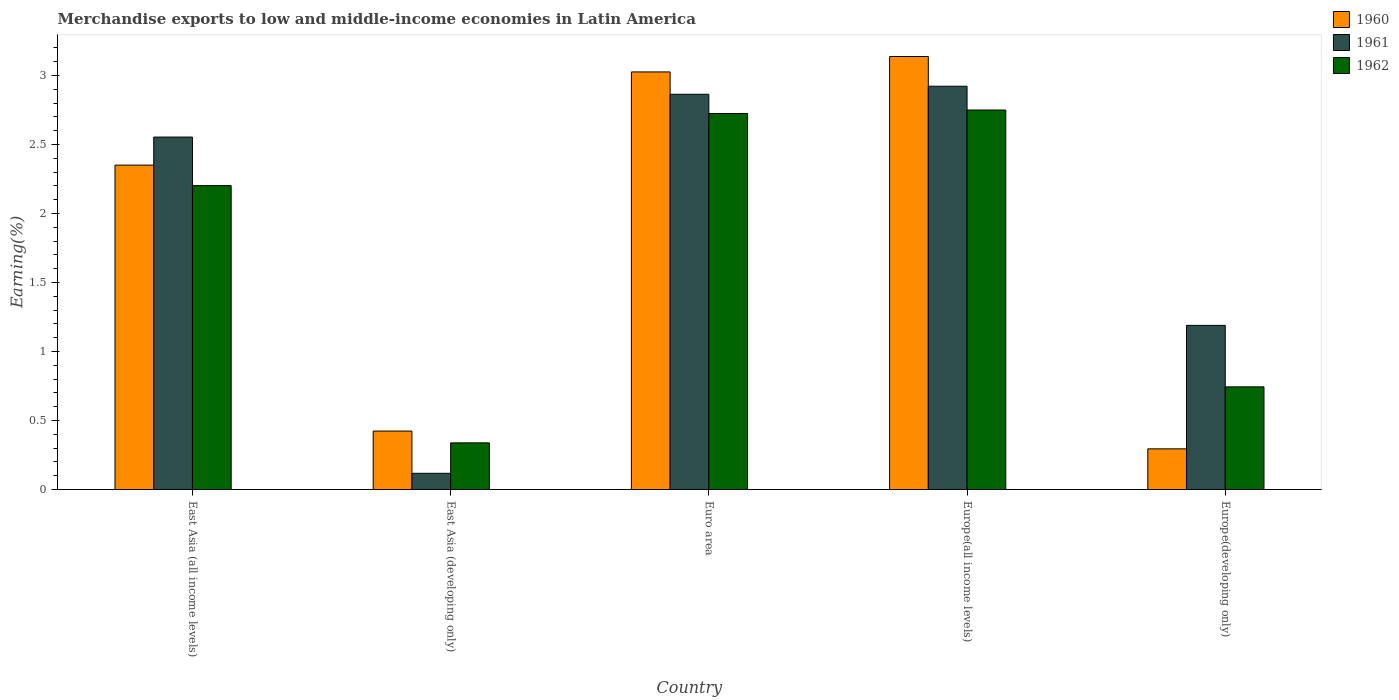How many different coloured bars are there?
Your response must be concise. 3. Are the number of bars per tick equal to the number of legend labels?
Your answer should be compact. Yes. Are the number of bars on each tick of the X-axis equal?
Your answer should be very brief. Yes. How many bars are there on the 3rd tick from the right?
Provide a succinct answer. 3. What is the label of the 1st group of bars from the left?
Provide a short and direct response. East Asia (all income levels). What is the percentage of amount earned from merchandise exports in 1960 in Europe(developing only)?
Make the answer very short. 0.29. Across all countries, what is the maximum percentage of amount earned from merchandise exports in 1960?
Keep it short and to the point. 3.14. Across all countries, what is the minimum percentage of amount earned from merchandise exports in 1960?
Your answer should be very brief. 0.29. In which country was the percentage of amount earned from merchandise exports in 1961 maximum?
Ensure brevity in your answer.  Europe(all income levels). In which country was the percentage of amount earned from merchandise exports in 1961 minimum?
Your response must be concise. East Asia (developing only). What is the total percentage of amount earned from merchandise exports in 1962 in the graph?
Your response must be concise. 8.76. What is the difference between the percentage of amount earned from merchandise exports in 1962 in East Asia (all income levels) and that in Euro area?
Make the answer very short. -0.52. What is the difference between the percentage of amount earned from merchandise exports in 1962 in Europe(all income levels) and the percentage of amount earned from merchandise exports in 1960 in Europe(developing only)?
Keep it short and to the point. 2.45. What is the average percentage of amount earned from merchandise exports in 1960 per country?
Provide a succinct answer. 1.85. What is the difference between the percentage of amount earned from merchandise exports of/in 1960 and percentage of amount earned from merchandise exports of/in 1961 in Europe(developing only)?
Offer a very short reply. -0.89. What is the ratio of the percentage of amount earned from merchandise exports in 1960 in East Asia (developing only) to that in Europe(all income levels)?
Your response must be concise. 0.13. Is the percentage of amount earned from merchandise exports in 1961 in East Asia (all income levels) less than that in Europe(developing only)?
Give a very brief answer. No. Is the difference between the percentage of amount earned from merchandise exports in 1960 in Euro area and Europe(all income levels) greater than the difference between the percentage of amount earned from merchandise exports in 1961 in Euro area and Europe(all income levels)?
Keep it short and to the point. No. What is the difference between the highest and the second highest percentage of amount earned from merchandise exports in 1961?
Offer a very short reply. 0.06. What is the difference between the highest and the lowest percentage of amount earned from merchandise exports in 1961?
Your response must be concise. 2.8. In how many countries, is the percentage of amount earned from merchandise exports in 1962 greater than the average percentage of amount earned from merchandise exports in 1962 taken over all countries?
Provide a succinct answer. 3. Is the sum of the percentage of amount earned from merchandise exports in 1962 in East Asia (developing only) and Europe(developing only) greater than the maximum percentage of amount earned from merchandise exports in 1961 across all countries?
Offer a terse response. No. What does the 2nd bar from the left in Europe(all income levels) represents?
Your answer should be compact. 1961. How many bars are there?
Your answer should be very brief. 15. What is the difference between two consecutive major ticks on the Y-axis?
Ensure brevity in your answer.  0.5. Does the graph contain any zero values?
Provide a succinct answer. No. Does the graph contain grids?
Your answer should be compact. No. What is the title of the graph?
Ensure brevity in your answer.  Merchandise exports to low and middle-income economies in Latin America. What is the label or title of the X-axis?
Ensure brevity in your answer.  Country. What is the label or title of the Y-axis?
Your answer should be compact. Earning(%). What is the Earning(%) in 1960 in East Asia (all income levels)?
Offer a very short reply. 2.35. What is the Earning(%) of 1961 in East Asia (all income levels)?
Your answer should be compact. 2.55. What is the Earning(%) of 1962 in East Asia (all income levels)?
Your answer should be compact. 2.2. What is the Earning(%) in 1960 in East Asia (developing only)?
Ensure brevity in your answer.  0.42. What is the Earning(%) in 1961 in East Asia (developing only)?
Give a very brief answer. 0.12. What is the Earning(%) of 1962 in East Asia (developing only)?
Offer a terse response. 0.34. What is the Earning(%) of 1960 in Euro area?
Offer a very short reply. 3.03. What is the Earning(%) in 1961 in Euro area?
Keep it short and to the point. 2.86. What is the Earning(%) of 1962 in Euro area?
Your response must be concise. 2.72. What is the Earning(%) of 1960 in Europe(all income levels)?
Make the answer very short. 3.14. What is the Earning(%) of 1961 in Europe(all income levels)?
Your answer should be compact. 2.92. What is the Earning(%) of 1962 in Europe(all income levels)?
Give a very brief answer. 2.75. What is the Earning(%) in 1960 in Europe(developing only)?
Give a very brief answer. 0.29. What is the Earning(%) in 1961 in Europe(developing only)?
Give a very brief answer. 1.19. What is the Earning(%) of 1962 in Europe(developing only)?
Keep it short and to the point. 0.74. Across all countries, what is the maximum Earning(%) of 1960?
Ensure brevity in your answer.  3.14. Across all countries, what is the maximum Earning(%) of 1961?
Your answer should be very brief. 2.92. Across all countries, what is the maximum Earning(%) in 1962?
Your response must be concise. 2.75. Across all countries, what is the minimum Earning(%) in 1960?
Provide a short and direct response. 0.29. Across all countries, what is the minimum Earning(%) of 1961?
Give a very brief answer. 0.12. Across all countries, what is the minimum Earning(%) in 1962?
Provide a succinct answer. 0.34. What is the total Earning(%) in 1960 in the graph?
Your answer should be very brief. 9.23. What is the total Earning(%) of 1961 in the graph?
Your answer should be compact. 9.65. What is the total Earning(%) of 1962 in the graph?
Your answer should be very brief. 8.76. What is the difference between the Earning(%) of 1960 in East Asia (all income levels) and that in East Asia (developing only)?
Keep it short and to the point. 1.93. What is the difference between the Earning(%) in 1961 in East Asia (all income levels) and that in East Asia (developing only)?
Your answer should be compact. 2.44. What is the difference between the Earning(%) in 1962 in East Asia (all income levels) and that in East Asia (developing only)?
Provide a short and direct response. 1.86. What is the difference between the Earning(%) of 1960 in East Asia (all income levels) and that in Euro area?
Keep it short and to the point. -0.68. What is the difference between the Earning(%) of 1961 in East Asia (all income levels) and that in Euro area?
Your response must be concise. -0.31. What is the difference between the Earning(%) in 1962 in East Asia (all income levels) and that in Euro area?
Provide a succinct answer. -0.52. What is the difference between the Earning(%) of 1960 in East Asia (all income levels) and that in Europe(all income levels)?
Provide a short and direct response. -0.79. What is the difference between the Earning(%) of 1961 in East Asia (all income levels) and that in Europe(all income levels)?
Offer a very short reply. -0.37. What is the difference between the Earning(%) of 1962 in East Asia (all income levels) and that in Europe(all income levels)?
Offer a terse response. -0.55. What is the difference between the Earning(%) in 1960 in East Asia (all income levels) and that in Europe(developing only)?
Keep it short and to the point. 2.06. What is the difference between the Earning(%) of 1961 in East Asia (all income levels) and that in Europe(developing only)?
Offer a terse response. 1.36. What is the difference between the Earning(%) of 1962 in East Asia (all income levels) and that in Europe(developing only)?
Make the answer very short. 1.46. What is the difference between the Earning(%) of 1960 in East Asia (developing only) and that in Euro area?
Your response must be concise. -2.6. What is the difference between the Earning(%) of 1961 in East Asia (developing only) and that in Euro area?
Keep it short and to the point. -2.75. What is the difference between the Earning(%) of 1962 in East Asia (developing only) and that in Euro area?
Provide a short and direct response. -2.39. What is the difference between the Earning(%) in 1960 in East Asia (developing only) and that in Europe(all income levels)?
Offer a very short reply. -2.71. What is the difference between the Earning(%) in 1961 in East Asia (developing only) and that in Europe(all income levels)?
Make the answer very short. -2.8. What is the difference between the Earning(%) of 1962 in East Asia (developing only) and that in Europe(all income levels)?
Keep it short and to the point. -2.41. What is the difference between the Earning(%) in 1960 in East Asia (developing only) and that in Europe(developing only)?
Your answer should be very brief. 0.13. What is the difference between the Earning(%) of 1961 in East Asia (developing only) and that in Europe(developing only)?
Your answer should be compact. -1.07. What is the difference between the Earning(%) in 1962 in East Asia (developing only) and that in Europe(developing only)?
Give a very brief answer. -0.41. What is the difference between the Earning(%) in 1960 in Euro area and that in Europe(all income levels)?
Give a very brief answer. -0.11. What is the difference between the Earning(%) of 1961 in Euro area and that in Europe(all income levels)?
Provide a short and direct response. -0.06. What is the difference between the Earning(%) of 1962 in Euro area and that in Europe(all income levels)?
Give a very brief answer. -0.03. What is the difference between the Earning(%) in 1960 in Euro area and that in Europe(developing only)?
Your answer should be compact. 2.73. What is the difference between the Earning(%) of 1961 in Euro area and that in Europe(developing only)?
Offer a terse response. 1.67. What is the difference between the Earning(%) in 1962 in Euro area and that in Europe(developing only)?
Your response must be concise. 1.98. What is the difference between the Earning(%) in 1960 in Europe(all income levels) and that in Europe(developing only)?
Offer a terse response. 2.84. What is the difference between the Earning(%) in 1961 in Europe(all income levels) and that in Europe(developing only)?
Provide a short and direct response. 1.73. What is the difference between the Earning(%) in 1962 in Europe(all income levels) and that in Europe(developing only)?
Keep it short and to the point. 2.01. What is the difference between the Earning(%) of 1960 in East Asia (all income levels) and the Earning(%) of 1961 in East Asia (developing only)?
Give a very brief answer. 2.23. What is the difference between the Earning(%) in 1960 in East Asia (all income levels) and the Earning(%) in 1962 in East Asia (developing only)?
Your answer should be very brief. 2.01. What is the difference between the Earning(%) of 1961 in East Asia (all income levels) and the Earning(%) of 1962 in East Asia (developing only)?
Ensure brevity in your answer.  2.22. What is the difference between the Earning(%) in 1960 in East Asia (all income levels) and the Earning(%) in 1961 in Euro area?
Give a very brief answer. -0.51. What is the difference between the Earning(%) in 1960 in East Asia (all income levels) and the Earning(%) in 1962 in Euro area?
Provide a succinct answer. -0.37. What is the difference between the Earning(%) in 1961 in East Asia (all income levels) and the Earning(%) in 1962 in Euro area?
Offer a very short reply. -0.17. What is the difference between the Earning(%) in 1960 in East Asia (all income levels) and the Earning(%) in 1961 in Europe(all income levels)?
Your answer should be very brief. -0.57. What is the difference between the Earning(%) in 1960 in East Asia (all income levels) and the Earning(%) in 1962 in Europe(all income levels)?
Your answer should be very brief. -0.4. What is the difference between the Earning(%) of 1961 in East Asia (all income levels) and the Earning(%) of 1962 in Europe(all income levels)?
Offer a terse response. -0.2. What is the difference between the Earning(%) in 1960 in East Asia (all income levels) and the Earning(%) in 1961 in Europe(developing only)?
Make the answer very short. 1.16. What is the difference between the Earning(%) in 1960 in East Asia (all income levels) and the Earning(%) in 1962 in Europe(developing only)?
Provide a short and direct response. 1.61. What is the difference between the Earning(%) in 1961 in East Asia (all income levels) and the Earning(%) in 1962 in Europe(developing only)?
Offer a terse response. 1.81. What is the difference between the Earning(%) of 1960 in East Asia (developing only) and the Earning(%) of 1961 in Euro area?
Provide a succinct answer. -2.44. What is the difference between the Earning(%) in 1960 in East Asia (developing only) and the Earning(%) in 1962 in Euro area?
Offer a terse response. -2.3. What is the difference between the Earning(%) of 1961 in East Asia (developing only) and the Earning(%) of 1962 in Euro area?
Your answer should be very brief. -2.61. What is the difference between the Earning(%) in 1960 in East Asia (developing only) and the Earning(%) in 1961 in Europe(all income levels)?
Your response must be concise. -2.5. What is the difference between the Earning(%) in 1960 in East Asia (developing only) and the Earning(%) in 1962 in Europe(all income levels)?
Ensure brevity in your answer.  -2.33. What is the difference between the Earning(%) of 1961 in East Asia (developing only) and the Earning(%) of 1962 in Europe(all income levels)?
Provide a short and direct response. -2.63. What is the difference between the Earning(%) of 1960 in East Asia (developing only) and the Earning(%) of 1961 in Europe(developing only)?
Make the answer very short. -0.77. What is the difference between the Earning(%) in 1960 in East Asia (developing only) and the Earning(%) in 1962 in Europe(developing only)?
Make the answer very short. -0.32. What is the difference between the Earning(%) in 1961 in East Asia (developing only) and the Earning(%) in 1962 in Europe(developing only)?
Offer a very short reply. -0.63. What is the difference between the Earning(%) of 1960 in Euro area and the Earning(%) of 1961 in Europe(all income levels)?
Offer a terse response. 0.1. What is the difference between the Earning(%) of 1960 in Euro area and the Earning(%) of 1962 in Europe(all income levels)?
Keep it short and to the point. 0.28. What is the difference between the Earning(%) in 1961 in Euro area and the Earning(%) in 1962 in Europe(all income levels)?
Offer a very short reply. 0.11. What is the difference between the Earning(%) in 1960 in Euro area and the Earning(%) in 1961 in Europe(developing only)?
Offer a terse response. 1.84. What is the difference between the Earning(%) of 1960 in Euro area and the Earning(%) of 1962 in Europe(developing only)?
Provide a succinct answer. 2.28. What is the difference between the Earning(%) in 1961 in Euro area and the Earning(%) in 1962 in Europe(developing only)?
Give a very brief answer. 2.12. What is the difference between the Earning(%) of 1960 in Europe(all income levels) and the Earning(%) of 1961 in Europe(developing only)?
Your answer should be very brief. 1.95. What is the difference between the Earning(%) of 1960 in Europe(all income levels) and the Earning(%) of 1962 in Europe(developing only)?
Provide a short and direct response. 2.39. What is the difference between the Earning(%) of 1961 in Europe(all income levels) and the Earning(%) of 1962 in Europe(developing only)?
Provide a succinct answer. 2.18. What is the average Earning(%) of 1960 per country?
Give a very brief answer. 1.85. What is the average Earning(%) in 1961 per country?
Make the answer very short. 1.93. What is the average Earning(%) of 1962 per country?
Provide a short and direct response. 1.75. What is the difference between the Earning(%) of 1960 and Earning(%) of 1961 in East Asia (all income levels)?
Provide a succinct answer. -0.2. What is the difference between the Earning(%) in 1960 and Earning(%) in 1962 in East Asia (all income levels)?
Keep it short and to the point. 0.15. What is the difference between the Earning(%) of 1961 and Earning(%) of 1962 in East Asia (all income levels)?
Keep it short and to the point. 0.35. What is the difference between the Earning(%) in 1960 and Earning(%) in 1961 in East Asia (developing only)?
Keep it short and to the point. 0.31. What is the difference between the Earning(%) of 1960 and Earning(%) of 1962 in East Asia (developing only)?
Your answer should be compact. 0.09. What is the difference between the Earning(%) in 1961 and Earning(%) in 1962 in East Asia (developing only)?
Your answer should be very brief. -0.22. What is the difference between the Earning(%) in 1960 and Earning(%) in 1961 in Euro area?
Your answer should be compact. 0.16. What is the difference between the Earning(%) of 1960 and Earning(%) of 1962 in Euro area?
Your answer should be very brief. 0.3. What is the difference between the Earning(%) in 1961 and Earning(%) in 1962 in Euro area?
Your answer should be very brief. 0.14. What is the difference between the Earning(%) in 1960 and Earning(%) in 1961 in Europe(all income levels)?
Make the answer very short. 0.22. What is the difference between the Earning(%) in 1960 and Earning(%) in 1962 in Europe(all income levels)?
Ensure brevity in your answer.  0.39. What is the difference between the Earning(%) in 1961 and Earning(%) in 1962 in Europe(all income levels)?
Make the answer very short. 0.17. What is the difference between the Earning(%) in 1960 and Earning(%) in 1961 in Europe(developing only)?
Give a very brief answer. -0.89. What is the difference between the Earning(%) of 1960 and Earning(%) of 1962 in Europe(developing only)?
Your response must be concise. -0.45. What is the difference between the Earning(%) of 1961 and Earning(%) of 1962 in Europe(developing only)?
Keep it short and to the point. 0.45. What is the ratio of the Earning(%) in 1960 in East Asia (all income levels) to that in East Asia (developing only)?
Give a very brief answer. 5.55. What is the ratio of the Earning(%) of 1961 in East Asia (all income levels) to that in East Asia (developing only)?
Offer a very short reply. 21.74. What is the ratio of the Earning(%) in 1962 in East Asia (all income levels) to that in East Asia (developing only)?
Provide a short and direct response. 6.51. What is the ratio of the Earning(%) of 1960 in East Asia (all income levels) to that in Euro area?
Offer a very short reply. 0.78. What is the ratio of the Earning(%) of 1961 in East Asia (all income levels) to that in Euro area?
Ensure brevity in your answer.  0.89. What is the ratio of the Earning(%) of 1962 in East Asia (all income levels) to that in Euro area?
Provide a succinct answer. 0.81. What is the ratio of the Earning(%) in 1960 in East Asia (all income levels) to that in Europe(all income levels)?
Your response must be concise. 0.75. What is the ratio of the Earning(%) of 1961 in East Asia (all income levels) to that in Europe(all income levels)?
Provide a short and direct response. 0.87. What is the ratio of the Earning(%) of 1962 in East Asia (all income levels) to that in Europe(all income levels)?
Your answer should be compact. 0.8. What is the ratio of the Earning(%) in 1960 in East Asia (all income levels) to that in Europe(developing only)?
Provide a short and direct response. 7.98. What is the ratio of the Earning(%) of 1961 in East Asia (all income levels) to that in Europe(developing only)?
Your answer should be very brief. 2.15. What is the ratio of the Earning(%) of 1962 in East Asia (all income levels) to that in Europe(developing only)?
Offer a terse response. 2.96. What is the ratio of the Earning(%) of 1960 in East Asia (developing only) to that in Euro area?
Make the answer very short. 0.14. What is the ratio of the Earning(%) of 1961 in East Asia (developing only) to that in Euro area?
Offer a terse response. 0.04. What is the ratio of the Earning(%) in 1962 in East Asia (developing only) to that in Euro area?
Your answer should be compact. 0.12. What is the ratio of the Earning(%) of 1960 in East Asia (developing only) to that in Europe(all income levels)?
Offer a terse response. 0.14. What is the ratio of the Earning(%) of 1961 in East Asia (developing only) to that in Europe(all income levels)?
Keep it short and to the point. 0.04. What is the ratio of the Earning(%) in 1962 in East Asia (developing only) to that in Europe(all income levels)?
Offer a terse response. 0.12. What is the ratio of the Earning(%) of 1960 in East Asia (developing only) to that in Europe(developing only)?
Provide a short and direct response. 1.44. What is the ratio of the Earning(%) of 1961 in East Asia (developing only) to that in Europe(developing only)?
Offer a terse response. 0.1. What is the ratio of the Earning(%) of 1962 in East Asia (developing only) to that in Europe(developing only)?
Your answer should be very brief. 0.45. What is the ratio of the Earning(%) of 1960 in Euro area to that in Europe(all income levels)?
Make the answer very short. 0.96. What is the ratio of the Earning(%) of 1961 in Euro area to that in Europe(all income levels)?
Your answer should be compact. 0.98. What is the ratio of the Earning(%) in 1962 in Euro area to that in Europe(all income levels)?
Offer a terse response. 0.99. What is the ratio of the Earning(%) in 1960 in Euro area to that in Europe(developing only)?
Offer a terse response. 10.27. What is the ratio of the Earning(%) in 1961 in Euro area to that in Europe(developing only)?
Your response must be concise. 2.41. What is the ratio of the Earning(%) in 1962 in Euro area to that in Europe(developing only)?
Your response must be concise. 3.66. What is the ratio of the Earning(%) in 1960 in Europe(all income levels) to that in Europe(developing only)?
Your answer should be compact. 10.65. What is the ratio of the Earning(%) of 1961 in Europe(all income levels) to that in Europe(developing only)?
Your answer should be compact. 2.46. What is the ratio of the Earning(%) in 1962 in Europe(all income levels) to that in Europe(developing only)?
Ensure brevity in your answer.  3.7. What is the difference between the highest and the second highest Earning(%) in 1960?
Your answer should be compact. 0.11. What is the difference between the highest and the second highest Earning(%) in 1961?
Offer a very short reply. 0.06. What is the difference between the highest and the second highest Earning(%) in 1962?
Offer a very short reply. 0.03. What is the difference between the highest and the lowest Earning(%) of 1960?
Offer a terse response. 2.84. What is the difference between the highest and the lowest Earning(%) of 1961?
Your response must be concise. 2.8. What is the difference between the highest and the lowest Earning(%) in 1962?
Give a very brief answer. 2.41. 